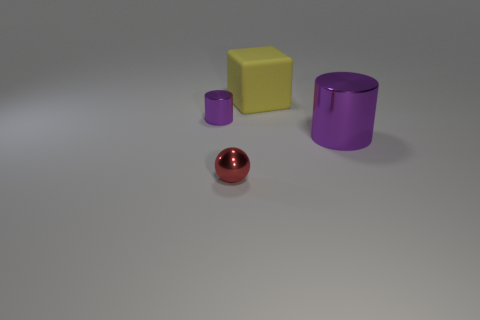Is there any other thing that is the same material as the large yellow thing?
Make the answer very short. No. What number of things are large red blocks or small cylinders?
Your answer should be compact. 1. How many objects are behind the metal ball and in front of the matte cube?
Keep it short and to the point. 2. There is a thing behind the small purple cylinder; what is its material?
Your answer should be compact. Rubber. There is another purple cylinder that is made of the same material as the tiny cylinder; what size is it?
Keep it short and to the point. Large. Do the purple cylinder that is left of the matte cube and the metal object that is in front of the big purple cylinder have the same size?
Your answer should be compact. Yes. There is a purple cylinder that is the same size as the metal sphere; what is it made of?
Provide a short and direct response. Metal. There is a object that is left of the large yellow thing and behind the large cylinder; what material is it?
Your answer should be very brief. Metal. Are there any tiny green metallic cubes?
Make the answer very short. No. There is a small metal cylinder; does it have the same color as the cylinder that is on the right side of the red metal ball?
Make the answer very short. Yes. 